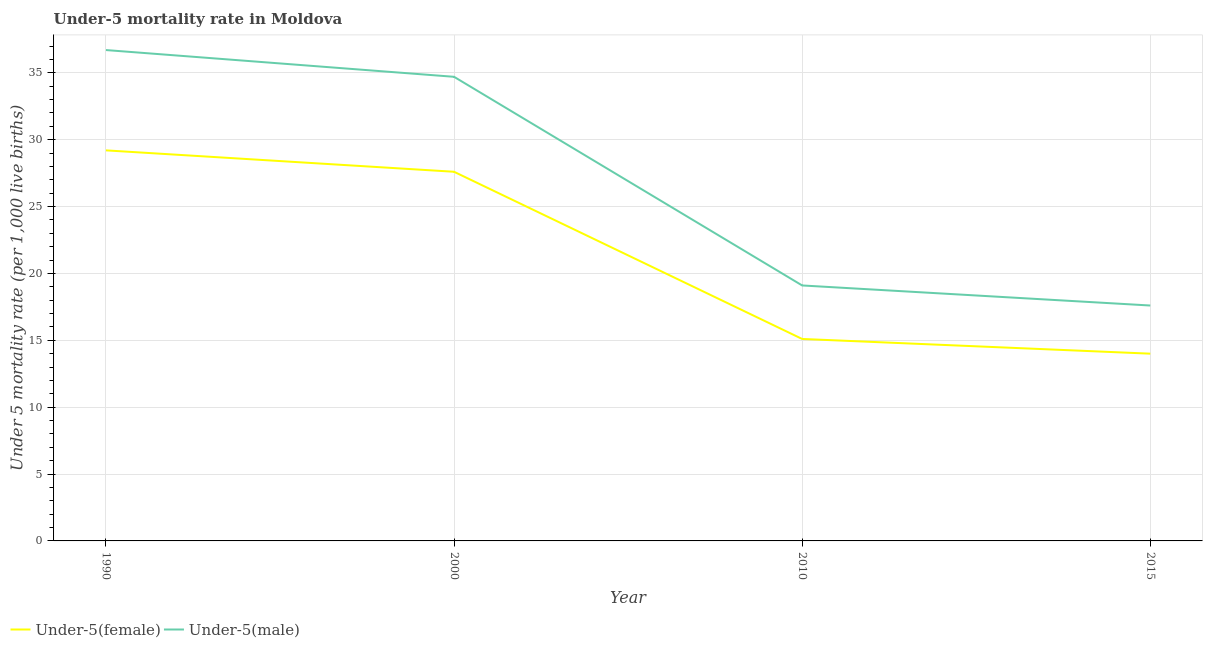Does the line corresponding to under-5 male mortality rate intersect with the line corresponding to under-5 female mortality rate?
Keep it short and to the point. No. What is the under-5 male mortality rate in 2000?
Offer a very short reply. 34.7. Across all years, what is the maximum under-5 male mortality rate?
Ensure brevity in your answer.  36.7. Across all years, what is the minimum under-5 male mortality rate?
Give a very brief answer. 17.6. In which year was the under-5 female mortality rate minimum?
Provide a succinct answer. 2015. What is the total under-5 male mortality rate in the graph?
Make the answer very short. 108.1. What is the difference between the under-5 female mortality rate in 1990 and that in 2015?
Make the answer very short. 15.2. What is the difference between the under-5 female mortality rate in 2000 and the under-5 male mortality rate in 2010?
Provide a succinct answer. 8.5. What is the average under-5 female mortality rate per year?
Ensure brevity in your answer.  21.47. In the year 1990, what is the difference between the under-5 male mortality rate and under-5 female mortality rate?
Keep it short and to the point. 7.5. What is the ratio of the under-5 male mortality rate in 2000 to that in 2015?
Offer a terse response. 1.97. What is the difference between the highest and the second highest under-5 female mortality rate?
Ensure brevity in your answer.  1.6. What is the difference between the highest and the lowest under-5 male mortality rate?
Ensure brevity in your answer.  19.1. Is the under-5 female mortality rate strictly greater than the under-5 male mortality rate over the years?
Offer a terse response. No. Is the under-5 female mortality rate strictly less than the under-5 male mortality rate over the years?
Your answer should be very brief. Yes. How many lines are there?
Keep it short and to the point. 2. How many years are there in the graph?
Provide a succinct answer. 4. What is the difference between two consecutive major ticks on the Y-axis?
Provide a short and direct response. 5. Are the values on the major ticks of Y-axis written in scientific E-notation?
Give a very brief answer. No. Does the graph contain any zero values?
Give a very brief answer. No. How many legend labels are there?
Offer a very short reply. 2. How are the legend labels stacked?
Provide a succinct answer. Horizontal. What is the title of the graph?
Provide a short and direct response. Under-5 mortality rate in Moldova. Does "Nitrous oxide emissions" appear as one of the legend labels in the graph?
Make the answer very short. No. What is the label or title of the X-axis?
Your response must be concise. Year. What is the label or title of the Y-axis?
Provide a succinct answer. Under 5 mortality rate (per 1,0 live births). What is the Under 5 mortality rate (per 1,000 live births) of Under-5(female) in 1990?
Provide a short and direct response. 29.2. What is the Under 5 mortality rate (per 1,000 live births) in Under-5(male) in 1990?
Your answer should be compact. 36.7. What is the Under 5 mortality rate (per 1,000 live births) in Under-5(female) in 2000?
Make the answer very short. 27.6. What is the Under 5 mortality rate (per 1,000 live births) of Under-5(male) in 2000?
Your response must be concise. 34.7. What is the Under 5 mortality rate (per 1,000 live births) of Under-5(female) in 2015?
Your answer should be compact. 14. Across all years, what is the maximum Under 5 mortality rate (per 1,000 live births) in Under-5(female)?
Offer a very short reply. 29.2. Across all years, what is the maximum Under 5 mortality rate (per 1,000 live births) in Under-5(male)?
Offer a very short reply. 36.7. Across all years, what is the minimum Under 5 mortality rate (per 1,000 live births) of Under-5(female)?
Your answer should be very brief. 14. Across all years, what is the minimum Under 5 mortality rate (per 1,000 live births) of Under-5(male)?
Your answer should be very brief. 17.6. What is the total Under 5 mortality rate (per 1,000 live births) of Under-5(female) in the graph?
Provide a short and direct response. 85.9. What is the total Under 5 mortality rate (per 1,000 live births) in Under-5(male) in the graph?
Give a very brief answer. 108.1. What is the difference between the Under 5 mortality rate (per 1,000 live births) in Under-5(male) in 1990 and that in 2000?
Give a very brief answer. 2. What is the difference between the Under 5 mortality rate (per 1,000 live births) of Under-5(female) in 1990 and that in 2010?
Keep it short and to the point. 14.1. What is the difference between the Under 5 mortality rate (per 1,000 live births) of Under-5(male) in 1990 and that in 2010?
Offer a very short reply. 17.6. What is the difference between the Under 5 mortality rate (per 1,000 live births) in Under-5(male) in 1990 and that in 2015?
Provide a short and direct response. 19.1. What is the difference between the Under 5 mortality rate (per 1,000 live births) of Under-5(female) in 2000 and that in 2010?
Offer a terse response. 12.5. What is the difference between the Under 5 mortality rate (per 1,000 live births) in Under-5(male) in 2000 and that in 2010?
Your answer should be compact. 15.6. What is the difference between the Under 5 mortality rate (per 1,000 live births) of Under-5(male) in 2000 and that in 2015?
Offer a terse response. 17.1. What is the difference between the Under 5 mortality rate (per 1,000 live births) in Under-5(male) in 2010 and that in 2015?
Your answer should be very brief. 1.5. What is the difference between the Under 5 mortality rate (per 1,000 live births) in Under-5(female) in 1990 and the Under 5 mortality rate (per 1,000 live births) in Under-5(male) in 2010?
Make the answer very short. 10.1. What is the difference between the Under 5 mortality rate (per 1,000 live births) in Under-5(female) in 1990 and the Under 5 mortality rate (per 1,000 live births) in Under-5(male) in 2015?
Provide a succinct answer. 11.6. What is the difference between the Under 5 mortality rate (per 1,000 live births) in Under-5(female) in 2000 and the Under 5 mortality rate (per 1,000 live births) in Under-5(male) in 2015?
Provide a short and direct response. 10. What is the difference between the Under 5 mortality rate (per 1,000 live births) of Under-5(female) in 2010 and the Under 5 mortality rate (per 1,000 live births) of Under-5(male) in 2015?
Give a very brief answer. -2.5. What is the average Under 5 mortality rate (per 1,000 live births) in Under-5(female) per year?
Provide a succinct answer. 21.48. What is the average Under 5 mortality rate (per 1,000 live births) in Under-5(male) per year?
Provide a short and direct response. 27.02. In the year 2000, what is the difference between the Under 5 mortality rate (per 1,000 live births) of Under-5(female) and Under 5 mortality rate (per 1,000 live births) of Under-5(male)?
Make the answer very short. -7.1. What is the ratio of the Under 5 mortality rate (per 1,000 live births) of Under-5(female) in 1990 to that in 2000?
Offer a very short reply. 1.06. What is the ratio of the Under 5 mortality rate (per 1,000 live births) of Under-5(male) in 1990 to that in 2000?
Your response must be concise. 1.06. What is the ratio of the Under 5 mortality rate (per 1,000 live births) of Under-5(female) in 1990 to that in 2010?
Offer a very short reply. 1.93. What is the ratio of the Under 5 mortality rate (per 1,000 live births) in Under-5(male) in 1990 to that in 2010?
Your response must be concise. 1.92. What is the ratio of the Under 5 mortality rate (per 1,000 live births) in Under-5(female) in 1990 to that in 2015?
Provide a short and direct response. 2.09. What is the ratio of the Under 5 mortality rate (per 1,000 live births) of Under-5(male) in 1990 to that in 2015?
Offer a very short reply. 2.09. What is the ratio of the Under 5 mortality rate (per 1,000 live births) in Under-5(female) in 2000 to that in 2010?
Provide a short and direct response. 1.83. What is the ratio of the Under 5 mortality rate (per 1,000 live births) in Under-5(male) in 2000 to that in 2010?
Your answer should be compact. 1.82. What is the ratio of the Under 5 mortality rate (per 1,000 live births) of Under-5(female) in 2000 to that in 2015?
Provide a succinct answer. 1.97. What is the ratio of the Under 5 mortality rate (per 1,000 live births) in Under-5(male) in 2000 to that in 2015?
Ensure brevity in your answer.  1.97. What is the ratio of the Under 5 mortality rate (per 1,000 live births) of Under-5(female) in 2010 to that in 2015?
Your answer should be compact. 1.08. What is the ratio of the Under 5 mortality rate (per 1,000 live births) of Under-5(male) in 2010 to that in 2015?
Offer a terse response. 1.09. 